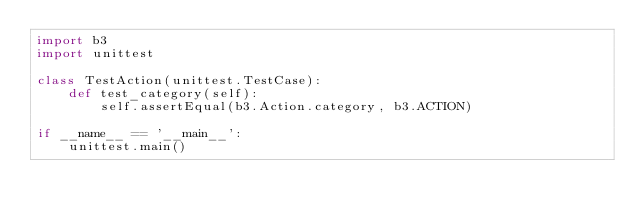<code> <loc_0><loc_0><loc_500><loc_500><_Python_>import b3
import unittest

class TestAction(unittest.TestCase):
    def test_category(self):
        self.assertEqual(b3.Action.category, b3.ACTION)

if __name__ == '__main__':
    unittest.main()</code> 